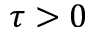<formula> <loc_0><loc_0><loc_500><loc_500>\tau > 0</formula> 